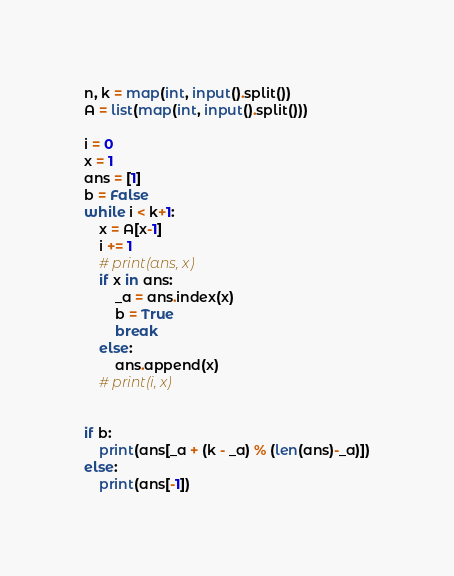<code> <loc_0><loc_0><loc_500><loc_500><_Python_>n, k = map(int, input().split())
A = list(map(int, input().split()))

i = 0
x = 1
ans = [1]
b = False
while i < k+1:
    x = A[x-1] 
    i += 1
    # print(ans, x)
    if x in ans:
        _a = ans.index(x)
        b = True
        break
    else:
        ans.append(x)
    # print(i, x)


if b:
    print(ans[_a + (k - _a) % (len(ans)-_a)])
else:
    print(ans[-1])
</code> 